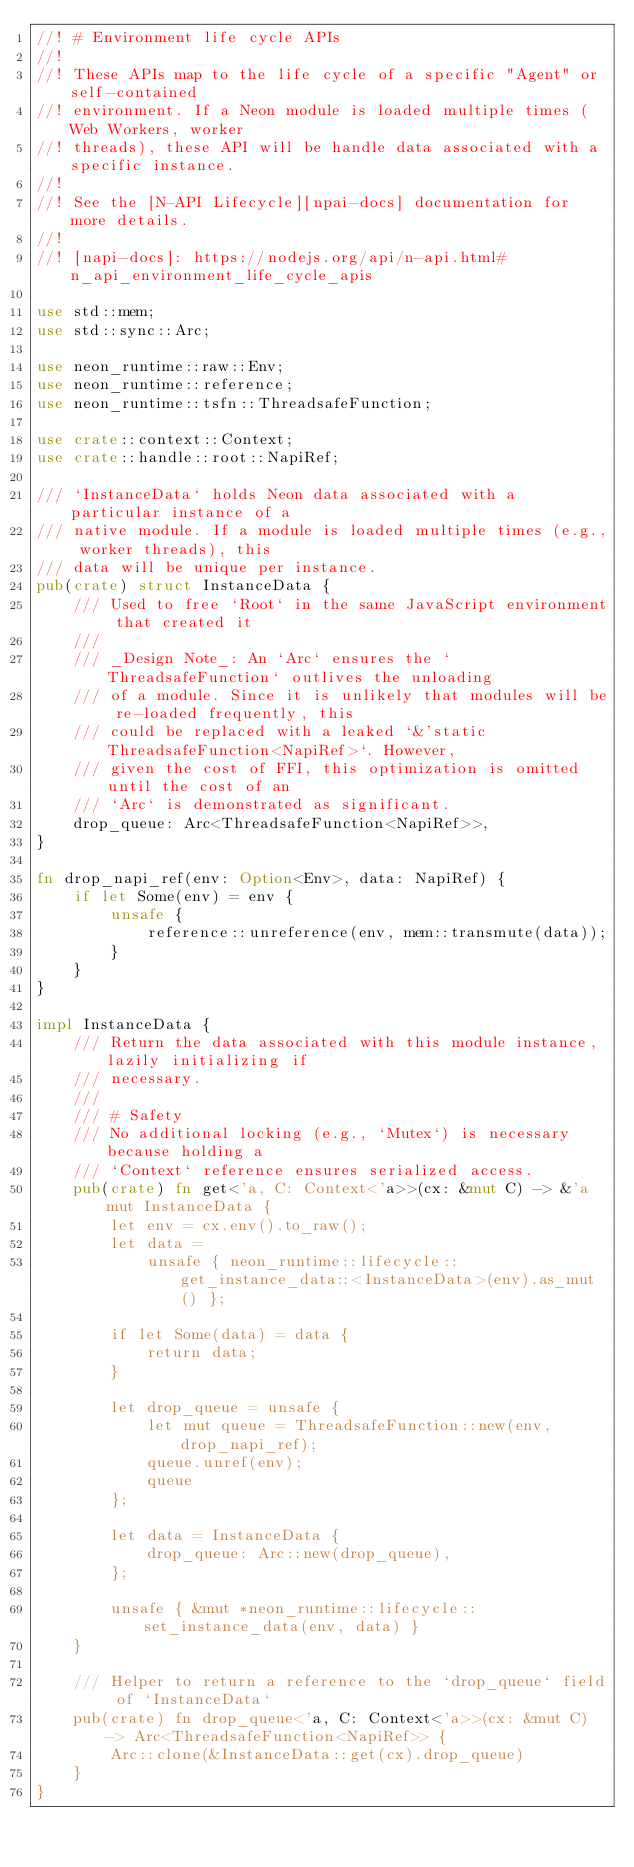Convert code to text. <code><loc_0><loc_0><loc_500><loc_500><_Rust_>//! # Environment life cycle APIs
//!
//! These APIs map to the life cycle of a specific "Agent" or self-contained
//! environment. If a Neon module is loaded multiple times (Web Workers, worker
//! threads), these API will be handle data associated with a specific instance.
//!
//! See the [N-API Lifecycle][npai-docs] documentation for more details.
//!
//! [napi-docs]: https://nodejs.org/api/n-api.html#n_api_environment_life_cycle_apis

use std::mem;
use std::sync::Arc;

use neon_runtime::raw::Env;
use neon_runtime::reference;
use neon_runtime::tsfn::ThreadsafeFunction;

use crate::context::Context;
use crate::handle::root::NapiRef;

/// `InstanceData` holds Neon data associated with a particular instance of a
/// native module. If a module is loaded multiple times (e.g., worker threads), this
/// data will be unique per instance.
pub(crate) struct InstanceData {
    /// Used to free `Root` in the same JavaScript environment that created it
    ///
    /// _Design Note_: An `Arc` ensures the `ThreadsafeFunction` outlives the unloading
    /// of a module. Since it is unlikely that modules will be re-loaded frequently, this
    /// could be replaced with a leaked `&'static ThreadsafeFunction<NapiRef>`. However,
    /// given the cost of FFI, this optimization is omitted until the cost of an
    /// `Arc` is demonstrated as significant.
    drop_queue: Arc<ThreadsafeFunction<NapiRef>>,
}

fn drop_napi_ref(env: Option<Env>, data: NapiRef) {
    if let Some(env) = env {
        unsafe {
            reference::unreference(env, mem::transmute(data));
        }
    }
}

impl InstanceData {
    /// Return the data associated with this module instance, lazily initializing if
    /// necessary.
    ///
    /// # Safety
    /// No additional locking (e.g., `Mutex`) is necessary because holding a
    /// `Context` reference ensures serialized access.
    pub(crate) fn get<'a, C: Context<'a>>(cx: &mut C) -> &'a mut InstanceData {
        let env = cx.env().to_raw();
        let data =
            unsafe { neon_runtime::lifecycle::get_instance_data::<InstanceData>(env).as_mut() };

        if let Some(data) = data {
            return data;
        }

        let drop_queue = unsafe {
            let mut queue = ThreadsafeFunction::new(env, drop_napi_ref);
            queue.unref(env);
            queue
        };

        let data = InstanceData {
            drop_queue: Arc::new(drop_queue),
        };

        unsafe { &mut *neon_runtime::lifecycle::set_instance_data(env, data) }
    }

    /// Helper to return a reference to the `drop_queue` field of `InstanceData`
    pub(crate) fn drop_queue<'a, C: Context<'a>>(cx: &mut C) -> Arc<ThreadsafeFunction<NapiRef>> {
        Arc::clone(&InstanceData::get(cx).drop_queue)
    }
}
</code> 